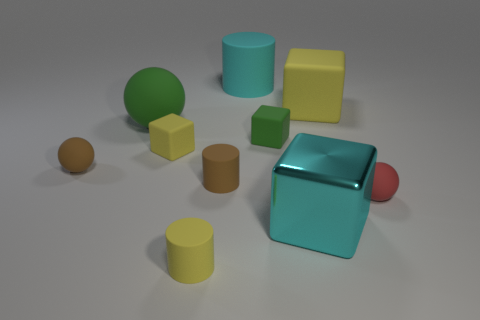Subtract all red blocks. Subtract all red balls. How many blocks are left? 4 Subtract all cubes. How many objects are left? 6 Subtract 0 cyan spheres. How many objects are left? 10 Subtract all large yellow metallic objects. Subtract all blocks. How many objects are left? 6 Add 2 yellow rubber cylinders. How many yellow rubber cylinders are left? 3 Add 6 big green shiny cylinders. How many big green shiny cylinders exist? 6 